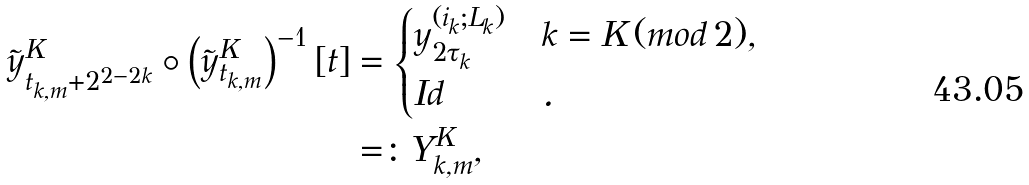<formula> <loc_0><loc_0><loc_500><loc_500>\tilde { y } _ { t _ { k , m } + 2 ^ { 2 - 2 k } } ^ { K } \circ \left ( \tilde { y } _ { t _ { k , m } } ^ { K } \right ) ^ { - 1 } [ t ] & = \begin{cases} y _ { 2 \tau _ { k } } ^ { ( i _ { k } ; L _ { k } ) } & k = K \, ( m o d \, 2 ) , \\ I d & . \end{cases} \\ & = \colon Y _ { k , m } ^ { K } ,</formula> 